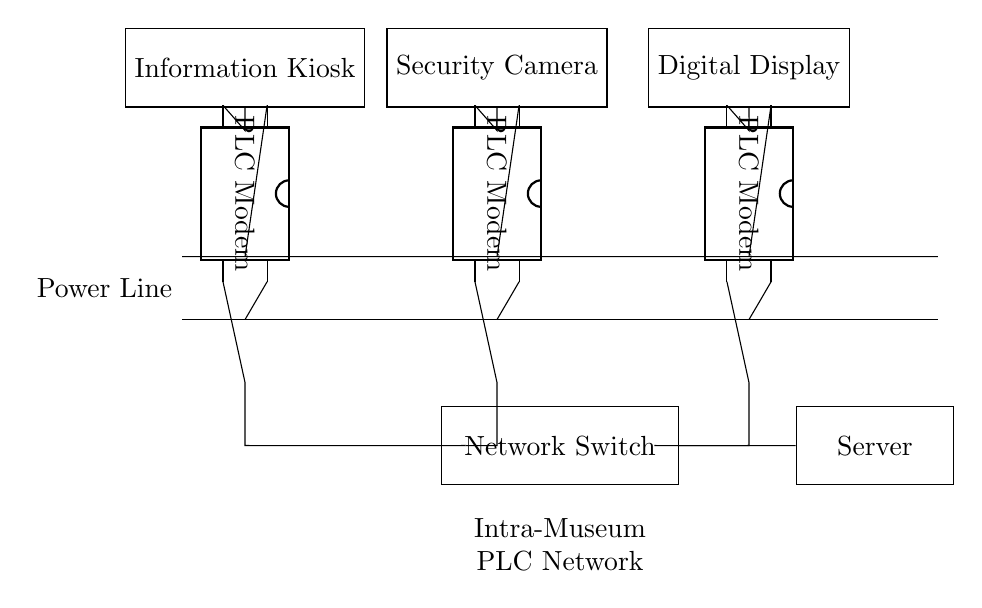What type of communication does this circuit utilize? The circuit uses Power Line Communication technology, which transmits data over the existing power lines.
Answer: Power Line Communication How many PLC modems are present in the circuit? By visually counting, there are three PLC modems connected to the power line.
Answer: Three What device connects to the PLC modem nearest to the left? The device connected to the leftmost PLC modem is an Information Kiosk.
Answer: Information Kiosk Which component is responsible for managing the network connections? The component that manages connections among devices is the Network Switch as shown in the diagram.
Answer: Network Switch Describe the purpose of the server in this circuit. The server functions as a central point for managing data and communications within the network created by the PLC technology.
Answer: Central management What is the total number of devices connected to the PLC modems? There are three devices connected in total: an Information Kiosk, a Security Camera, and a Digital Display.
Answer: Three devices Which modem is connected to the Security Camera? The Security Camera is connected to the second PLC modem from the left in the circuit diagram.
Answer: Second PLC modem 